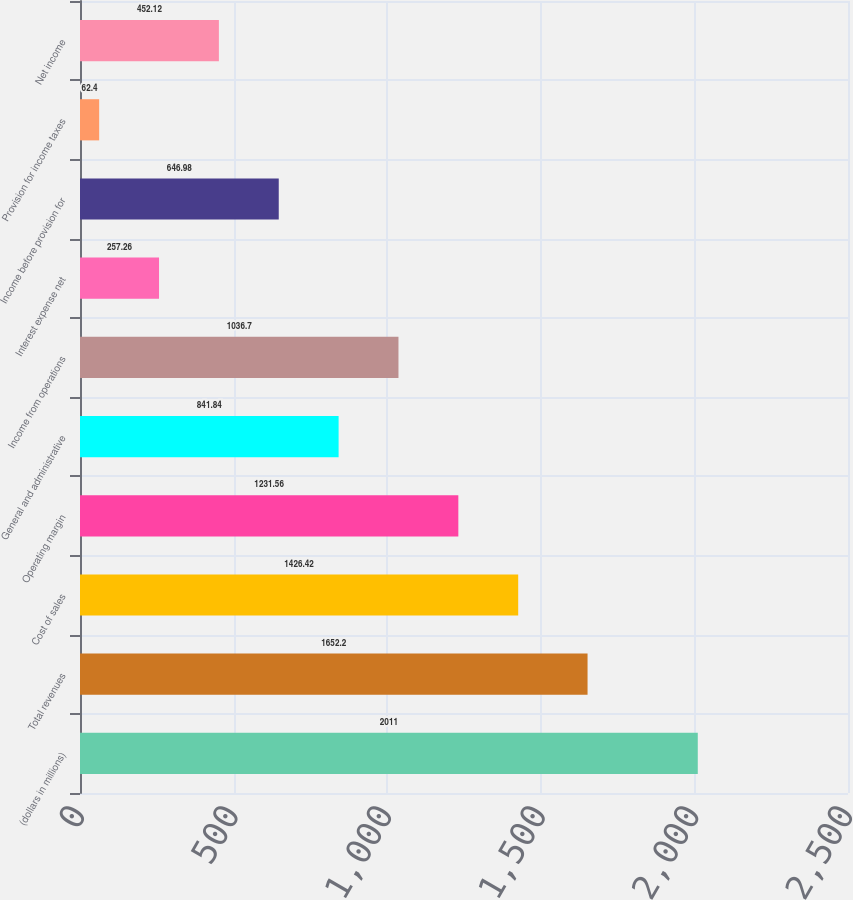<chart> <loc_0><loc_0><loc_500><loc_500><bar_chart><fcel>(dollars in millions)<fcel>Total revenues<fcel>Cost of sales<fcel>Operating margin<fcel>General and administrative<fcel>Income from operations<fcel>Interest expense net<fcel>Income before provision for<fcel>Provision for income taxes<fcel>Net income<nl><fcel>2011<fcel>1652.2<fcel>1426.42<fcel>1231.56<fcel>841.84<fcel>1036.7<fcel>257.26<fcel>646.98<fcel>62.4<fcel>452.12<nl></chart> 